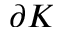Convert formula to latex. <formula><loc_0><loc_0><loc_500><loc_500>\partial K</formula> 